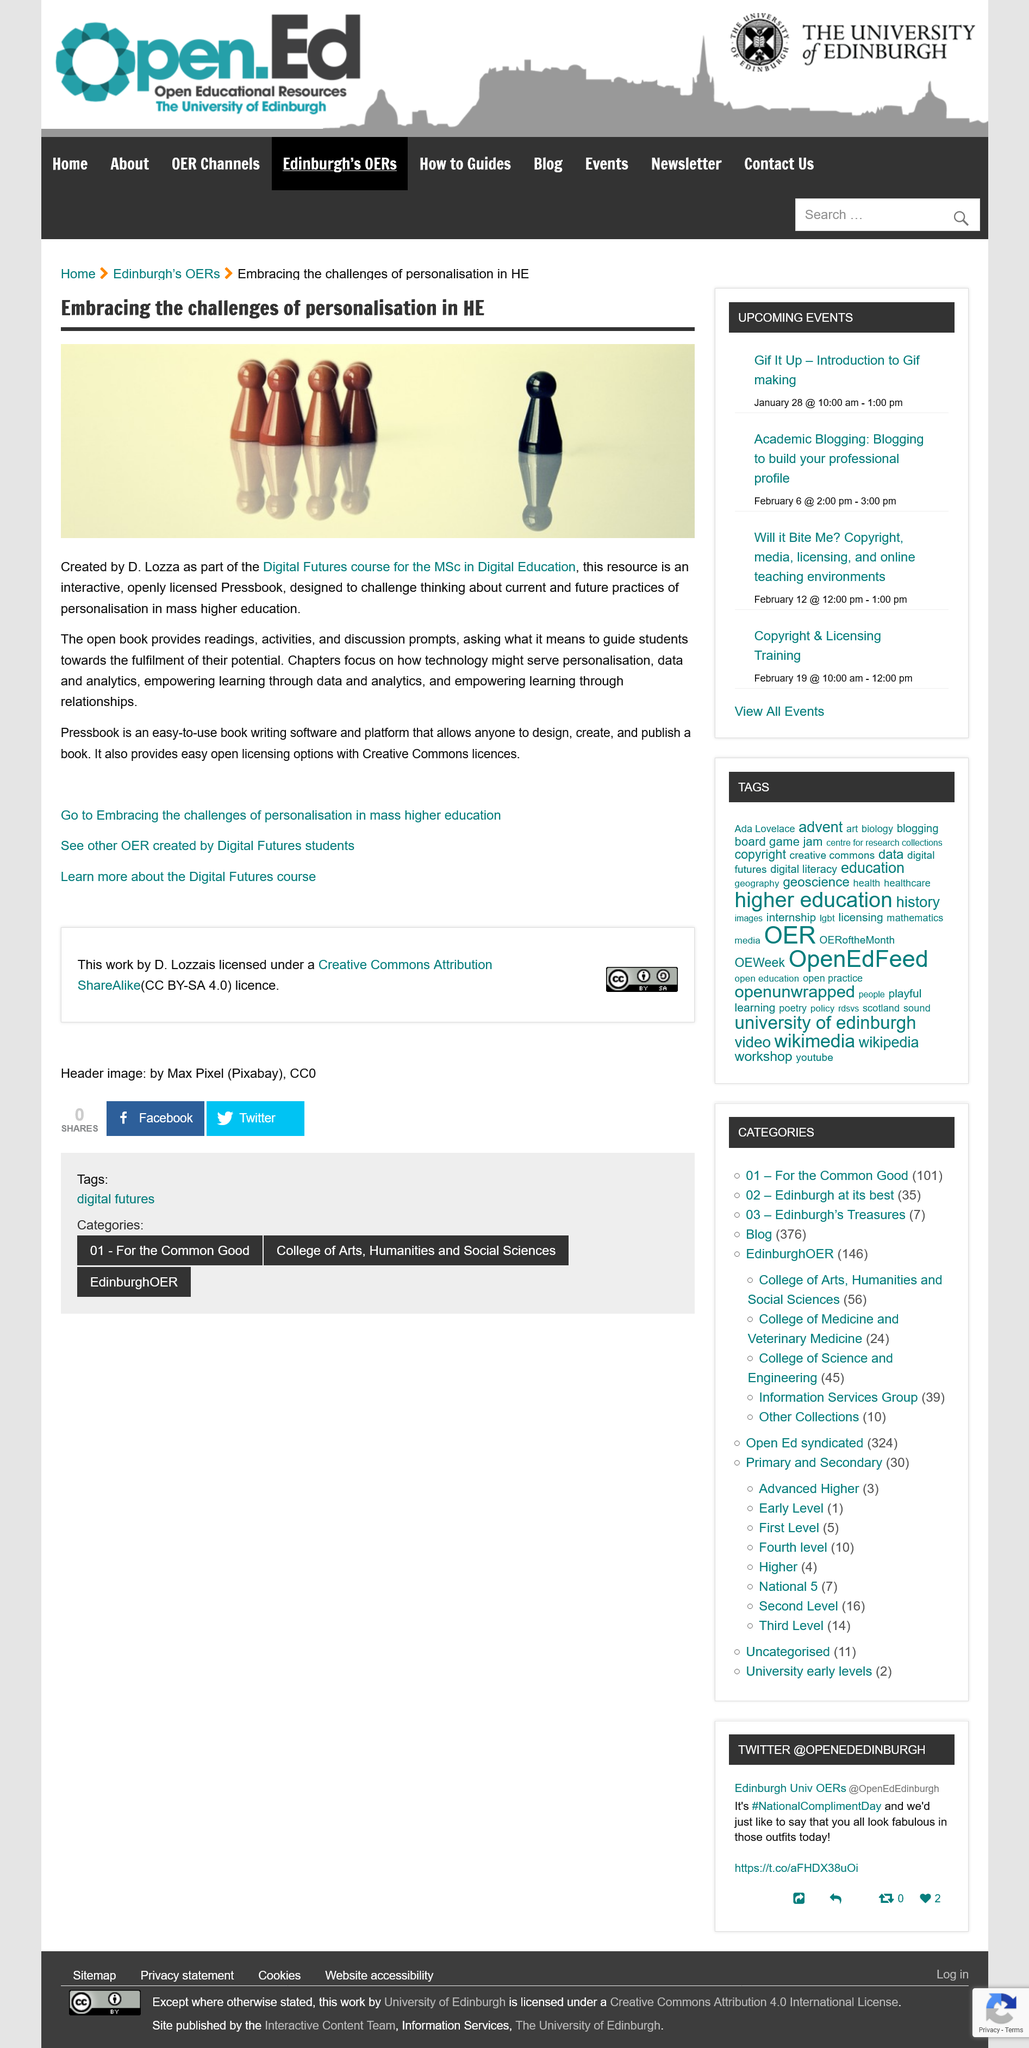List a handful of essential elements in this visual. The Digital Futures course uses open licensing software, specifically Pressbook, which is available for use. Pressbook uses open licensing with Creative Commons licenses. D. Lozza created Pressbook. 